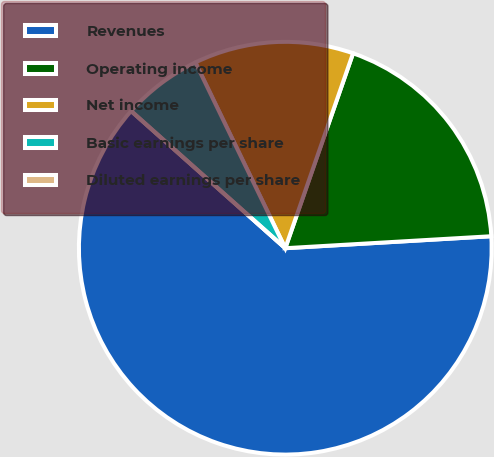Convert chart. <chart><loc_0><loc_0><loc_500><loc_500><pie_chart><fcel>Revenues<fcel>Operating income<fcel>Net income<fcel>Basic earnings per share<fcel>Diluted earnings per share<nl><fcel>62.5%<fcel>18.75%<fcel>12.5%<fcel>6.25%<fcel>0.0%<nl></chart> 